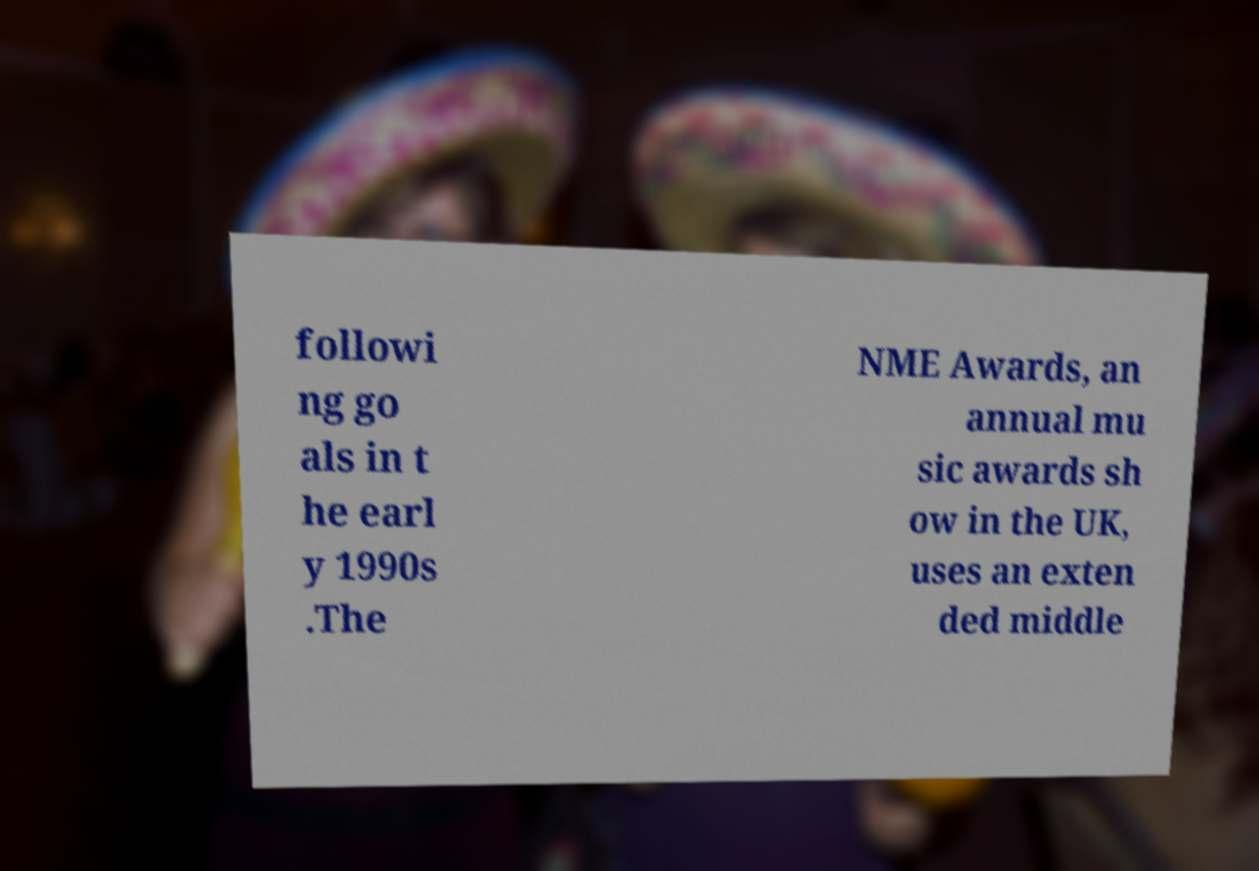I need the written content from this picture converted into text. Can you do that? followi ng go als in t he earl y 1990s .The NME Awards, an annual mu sic awards sh ow in the UK, uses an exten ded middle 